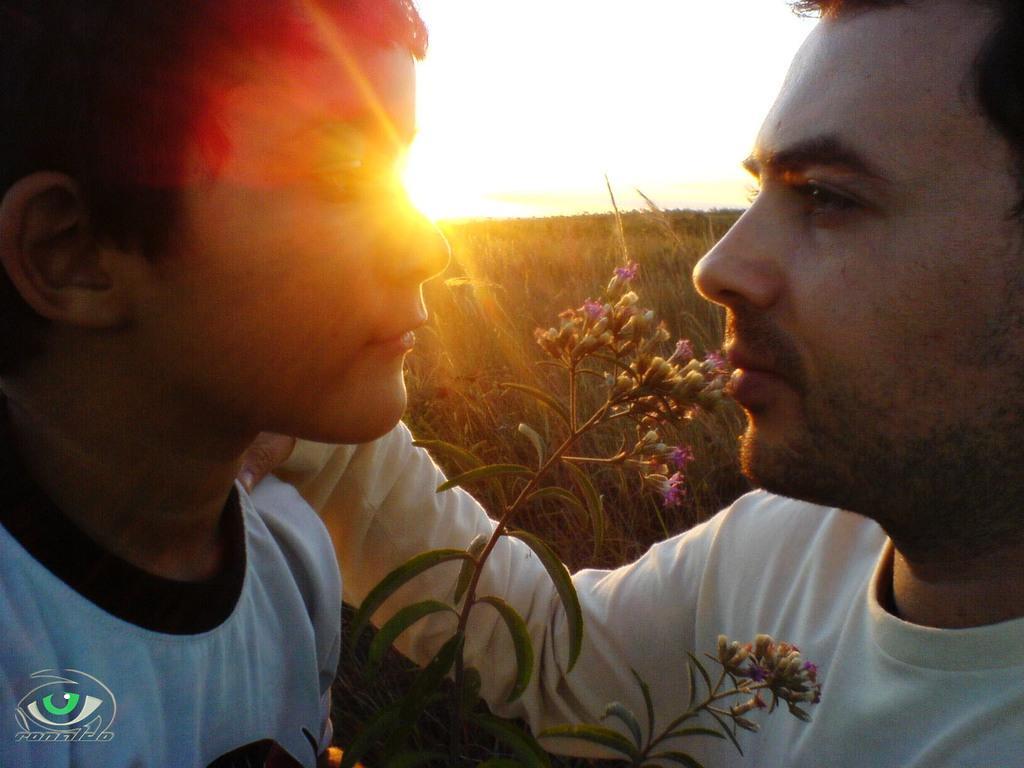In one or two sentences, can you explain what this image depicts? In this image, we can see a person and kid wearing clothes. There is a plant at the bottom of the image. At the top of the image, we can see the sky. 